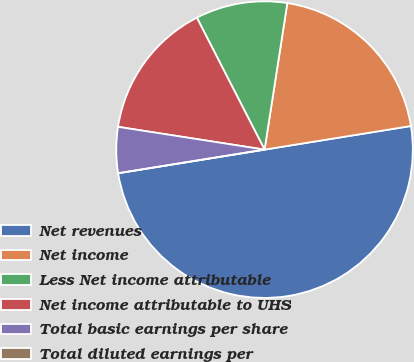Convert chart. <chart><loc_0><loc_0><loc_500><loc_500><pie_chart><fcel>Net revenues<fcel>Net income<fcel>Less Net income attributable<fcel>Net income attributable to UHS<fcel>Total basic earnings per share<fcel>Total diluted earnings per<nl><fcel>50.0%<fcel>20.0%<fcel>10.0%<fcel>15.0%<fcel>5.0%<fcel>0.0%<nl></chart> 